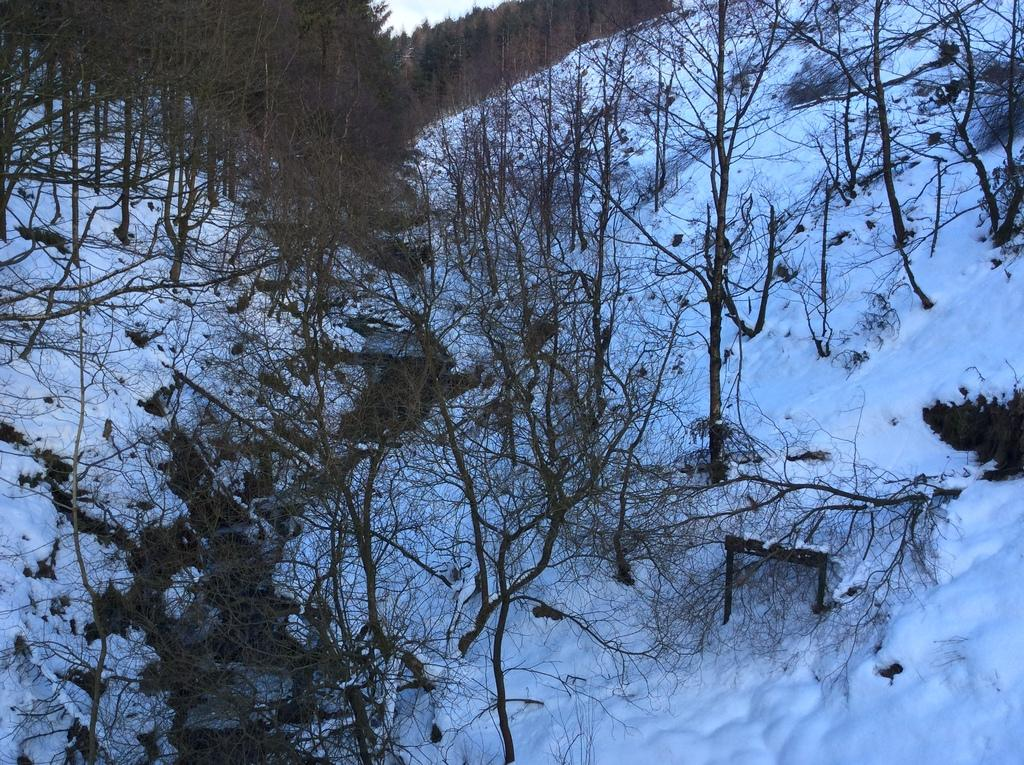What is the primary weather condition depicted in the image? There is snow in the image. What type of vegetation can be seen in the image? There are trees with branches and leaves in the image. How many brothers are playing in the snow in the image? There are no brothers present in the image; it only features snow and trees. What type of apparel are the trees wearing in the image? Trees do not wear apparel, so this question cannot be answered. 